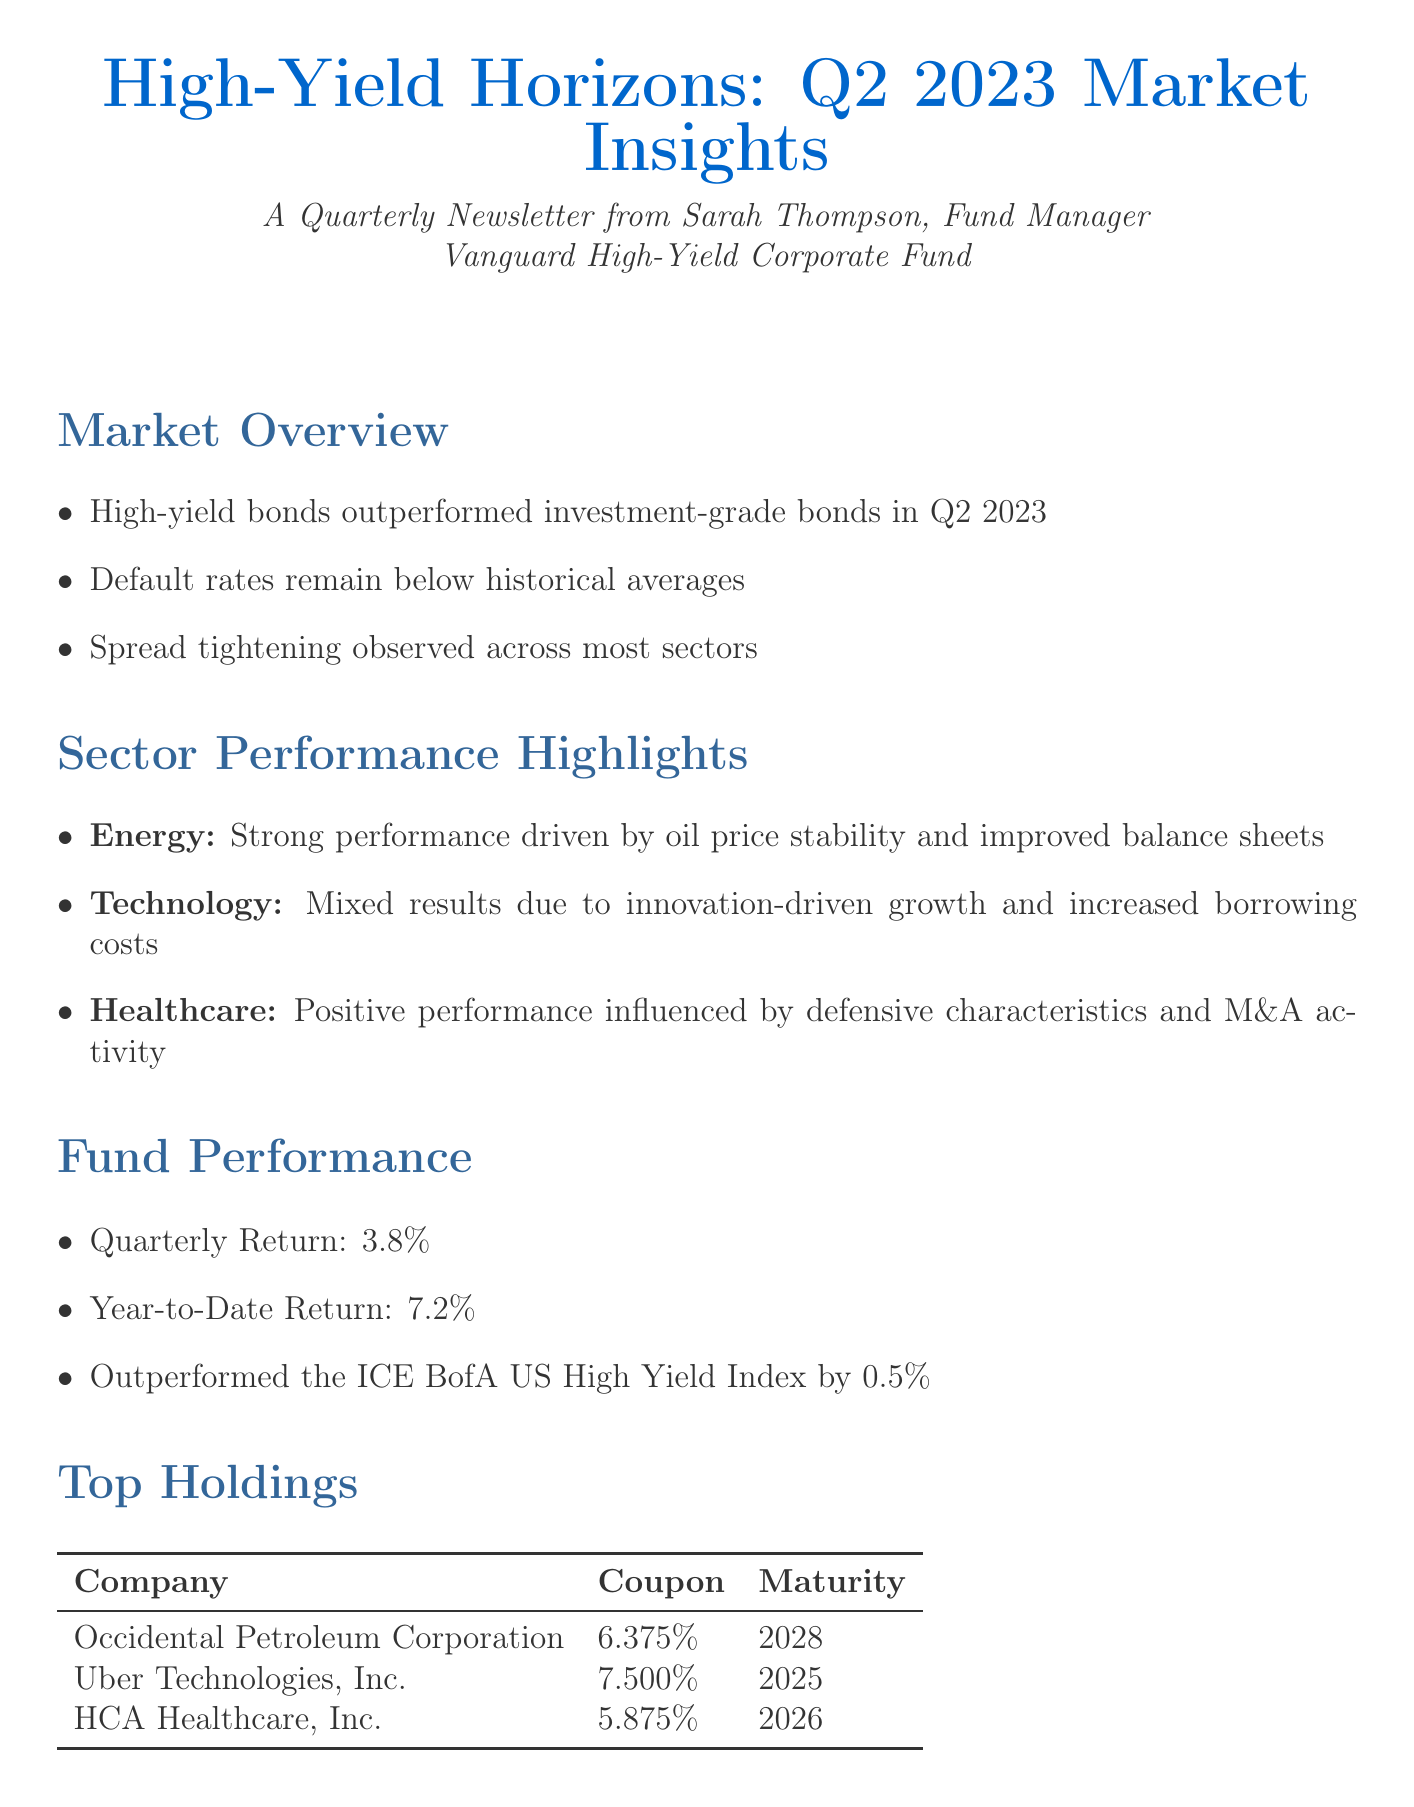What is the quarterly return of the fund? The quarterly return of the fund is listed directly in the document under "Fund Performance."
Answer: 3.8% Who is the fund manager? The fund manager's name is mentioned at the beginning of the document.
Answer: Sarah Thompson What sector had a strong performance? The sector performance is outlined, and the strong sector is specifically mentioned.
Answer: Energy What is the YTD return of the fund? The YTD return figure can be found in the "Fund Performance" section of the document.
Answer: 7.2% What is a positive factor for the market outlook? The document lists several positive factors, and one example can be found in the "Market Outlook" section.
Answer: Improving corporate fundamentals How much did the fund outperform the ICE BofA US High Yield Index? The comparison is stated in the "Fund Performance" section, outlining how the fund performed against the benchmark.
Answer: 0.5% What is the investment strategy focus? The focus of the investment strategy is outlined in the "Investment Strategy" section of the document.
Answer: Quality-driven selection Which company has the highest coupon in the top holdings? The document presents a table of top holdings, indicating the respective coupon rates for each company.
Answer: Uber Technologies, Inc 